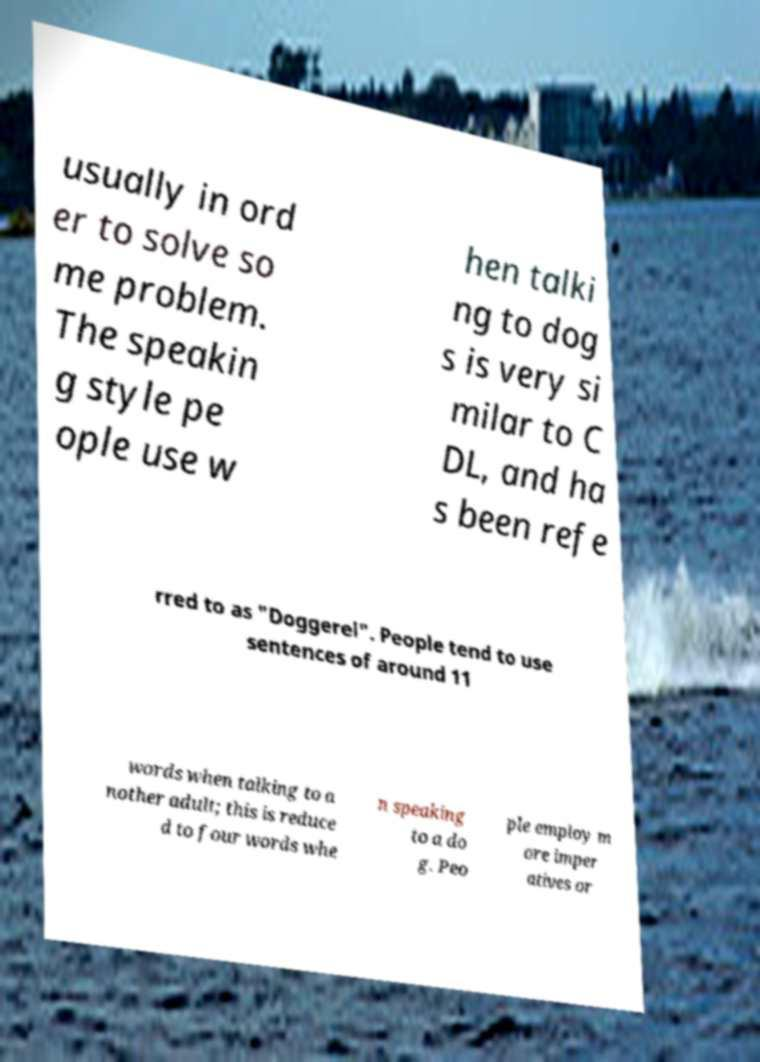Please identify and transcribe the text found in this image. usually in ord er to solve so me problem. The speakin g style pe ople use w hen talki ng to dog s is very si milar to C DL, and ha s been refe rred to as "Doggerel". People tend to use sentences of around 11 words when talking to a nother adult; this is reduce d to four words whe n speaking to a do g. Peo ple employ m ore imper atives or 